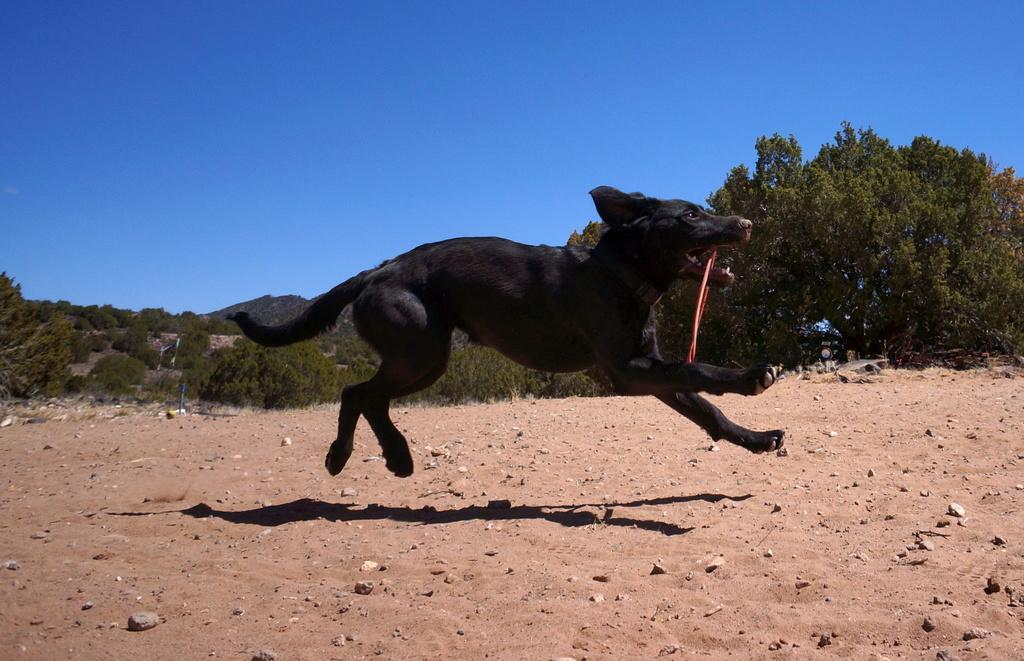What type of animal is in the image? There is a dog in the image. What is the dog doing in the image? The dog is running towards the right. What color is the dog? The dog is black in color. What type of terrain is visible at the bottom of the image? There is sand at the bottom of the image. What can be seen in the background of the image? There are trees and the sky visible in the background of the image. What type of comb is the dog using to exchange with the church in the image? There is no comb or church present in the image. The image features a black dog running on sand, with trees and the sky visible in the background. 